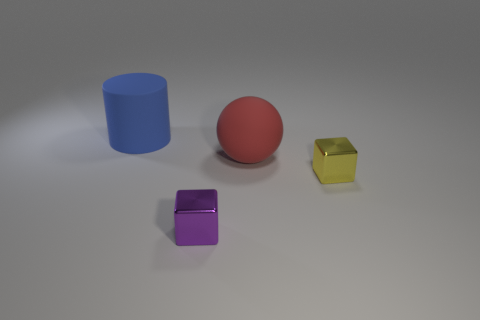Subtract all balls. How many objects are left? 3 Add 3 big gray spheres. How many objects exist? 7 Subtract all tiny brown matte things. Subtract all small blocks. How many objects are left? 2 Add 4 purple objects. How many purple objects are left? 5 Add 4 matte objects. How many matte objects exist? 6 Subtract 0 gray blocks. How many objects are left? 4 